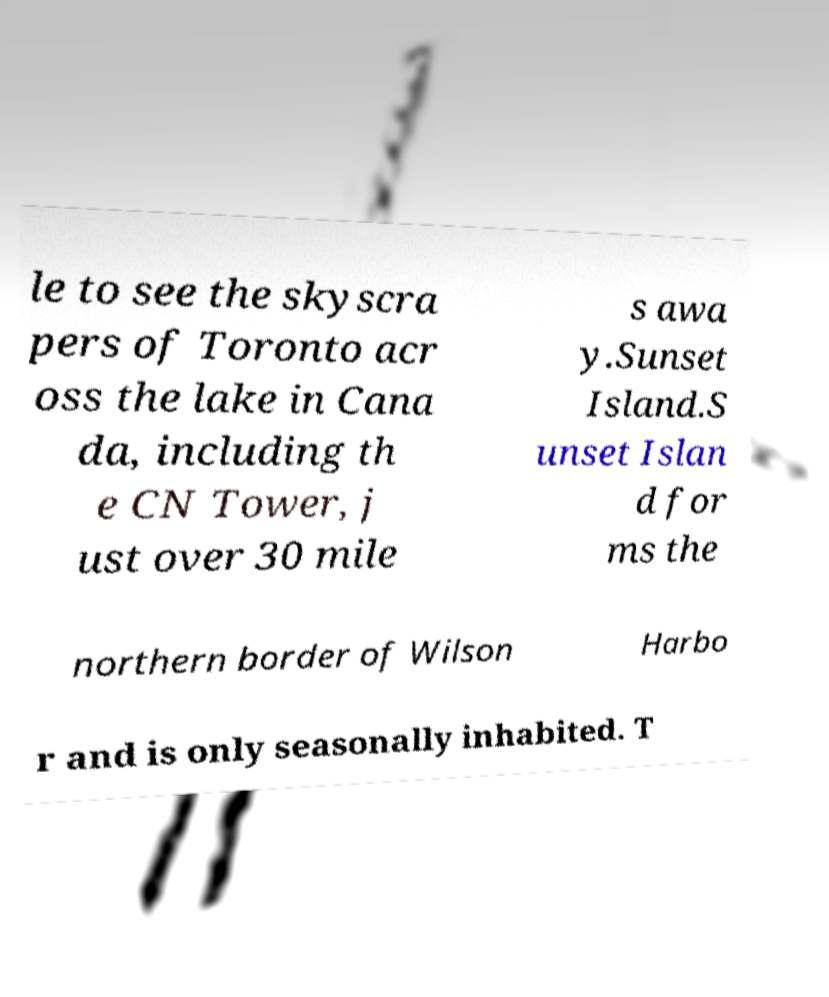Could you extract and type out the text from this image? le to see the skyscra pers of Toronto acr oss the lake in Cana da, including th e CN Tower, j ust over 30 mile s awa y.Sunset Island.S unset Islan d for ms the northern border of Wilson Harbo r and is only seasonally inhabited. T 